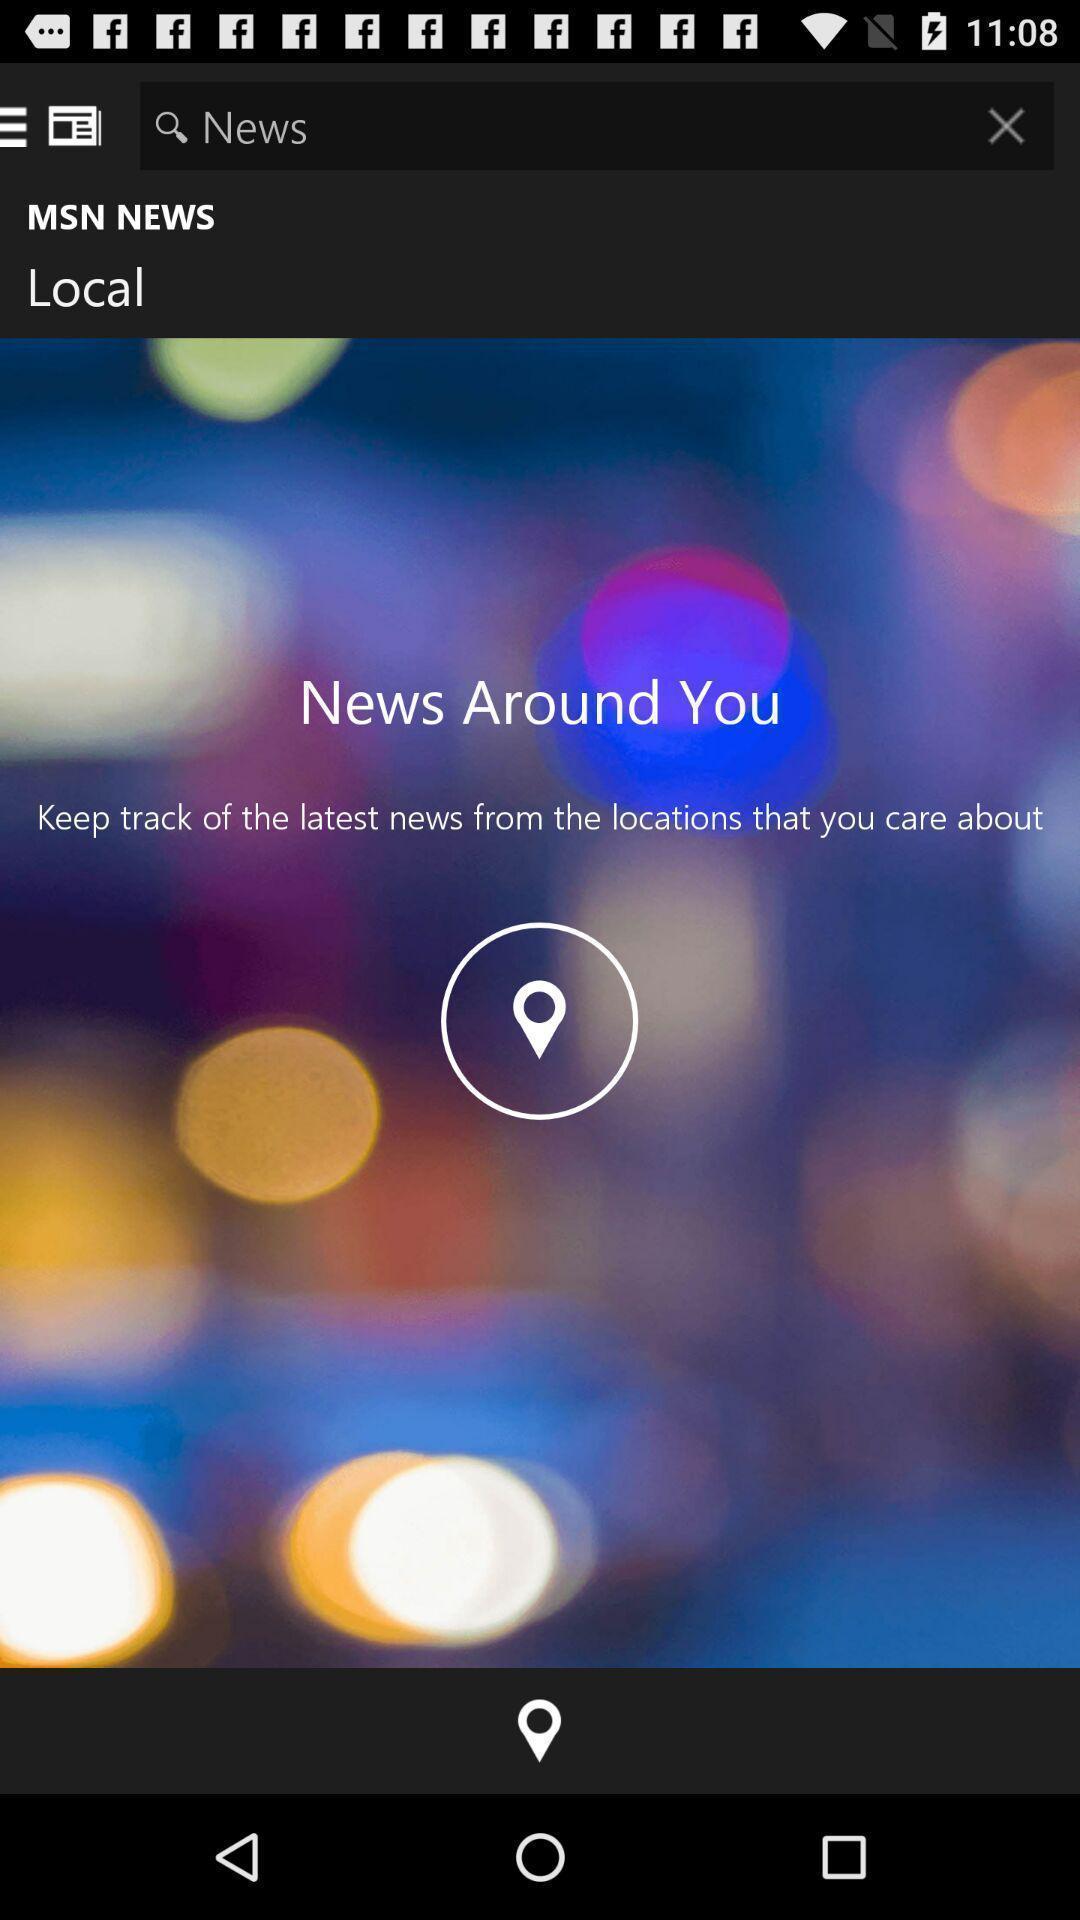Describe this image in words. Screen displaying a search bar in a news application. 